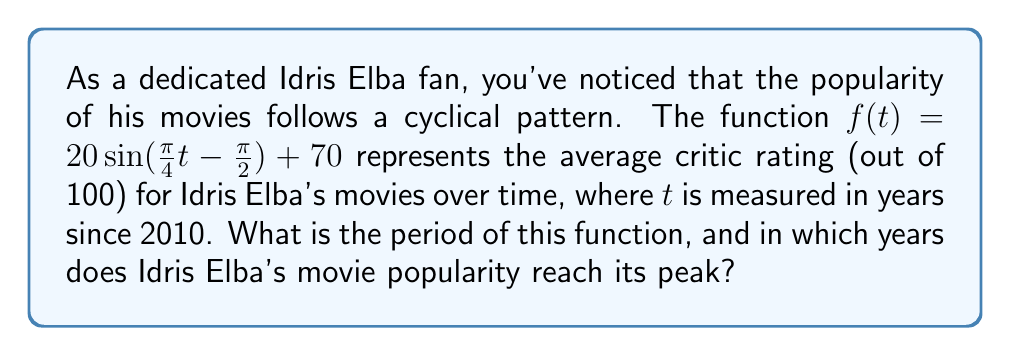What is the answer to this math problem? To solve this problem, let's follow these steps:

1) The general form of a sine function is:
   $$f(t) = A \sin(B(t - C)) + D$$
   where $A$ is the amplitude, $B$ is the angular frequency, $C$ is the phase shift, and $D$ is the vertical shift.

2) In our function $f(t) = 20 \sin(\frac{\pi}{4}t - \frac{\pi}{2}) + 70$, we can identify:
   $A = 20$, $B = \frac{\pi}{4}$, $C = 0$, and $D = 70$

3) The period of a sine function is given by the formula:
   $$\text{Period} = \frac{2\pi}{|B|} = \frac{2\pi}{|\frac{\pi}{4}|} = 8$$

4) This means the popularity cycle repeats every 8 years.

5) To find the peak years, we need to solve:
   $$\frac{\pi}{4}t - \frac{\pi}{2} = \frac{\pi}{2} + 2\pi n$$
   where $n$ is any integer.

6) Solving this equation:
   $$\frac{\pi}{4}t = \pi + 2\pi n$$
   $$t = 4 + 8n$$

7) Since $t$ is measured in years since 2010, the peak years are:
   2014, 2022, 2030, and so on, occurring every 8 years.
Answer: Period: 8 years; Peak years: 2014, 2022, 2030, ... 